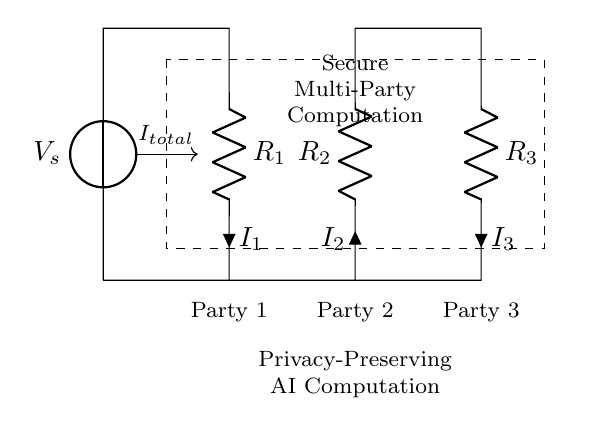What is the total current entering the circuit? The total current entering the circuit, denoted as I total, is depicted by the arrow pointing toward the current source V s. This total current is divided among the three resistors in the circuit.
Answer: I total What are the three resistors labeled as? The three resistors in the circuit are labeled R 1, R 2, and R 3, indicating their positions and contributions to the current division.
Answer: R 1, R 2, R 3 What is the role of secure multi-party computation in this circuit? The dashed rectangle labeled "Secure Multi-Party Computation" indicates that the circuit is designed for a specific application involving multiple parties working together while preserving data privacy.
Answer: Privacy How does the current divide among the resistors? In a current divider, the current is divided inversely proportional to the resistance values. Therefore, the current flowing through each resistor can be calculated using the formula derived from Ohm’s law, considering the resistor values R 1, R 2, and R 3.
Answer: Inversely proportional What do the labels Party 1, Party 2, and Party 3 represent? The labels Party 1, Party 2, and Party 3 below the circuit indicate that these components correspond to different parties involved in the computation, emphasizing the collaborative aspect of multi-party computation in AI.
Answer: Parties Which resistor carries the lowest current if R 2 is the largest resistor? Since current divides inversely based on resistance, the resistor with the largest value will carry the lowest current. Therefore, if R 2 is the largest resistor, I 2 will be the lowest current.
Answer: I 2 